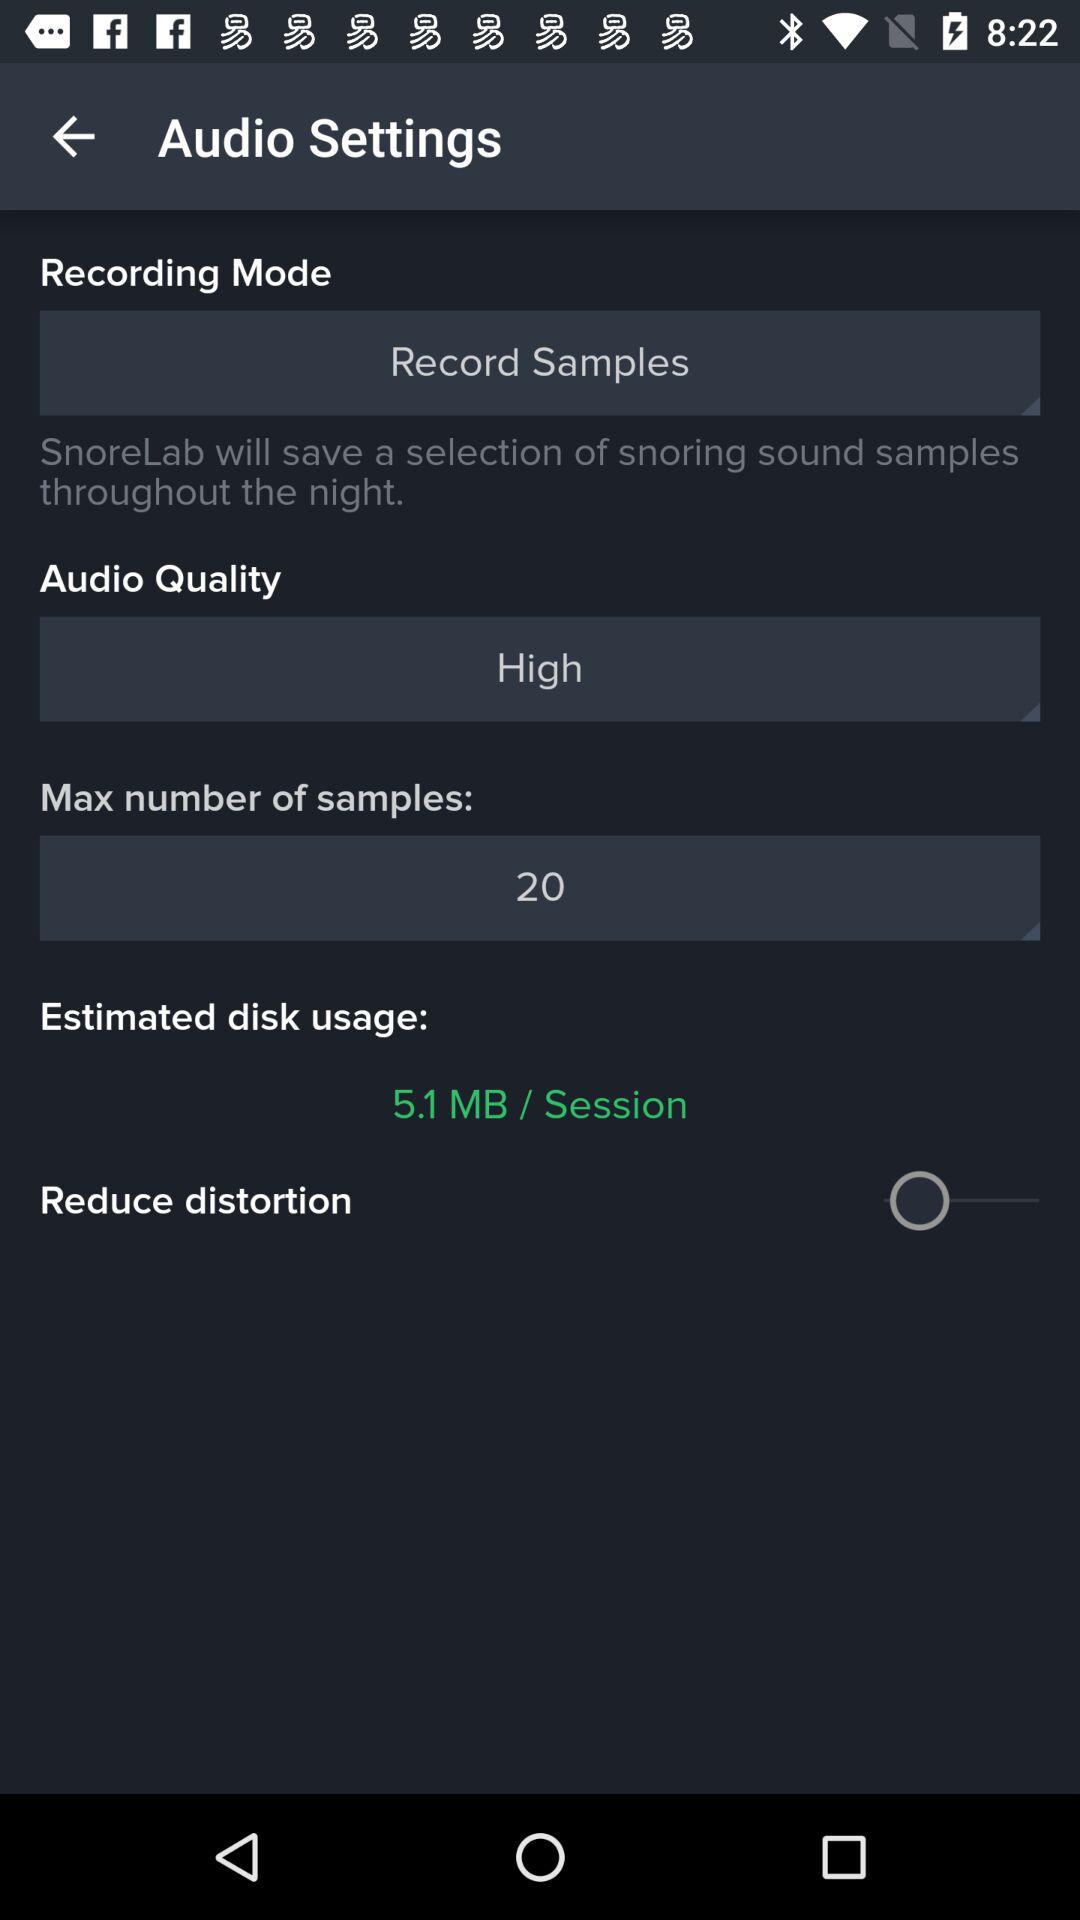What is the selected audio quality? The selected audio quality is high. 